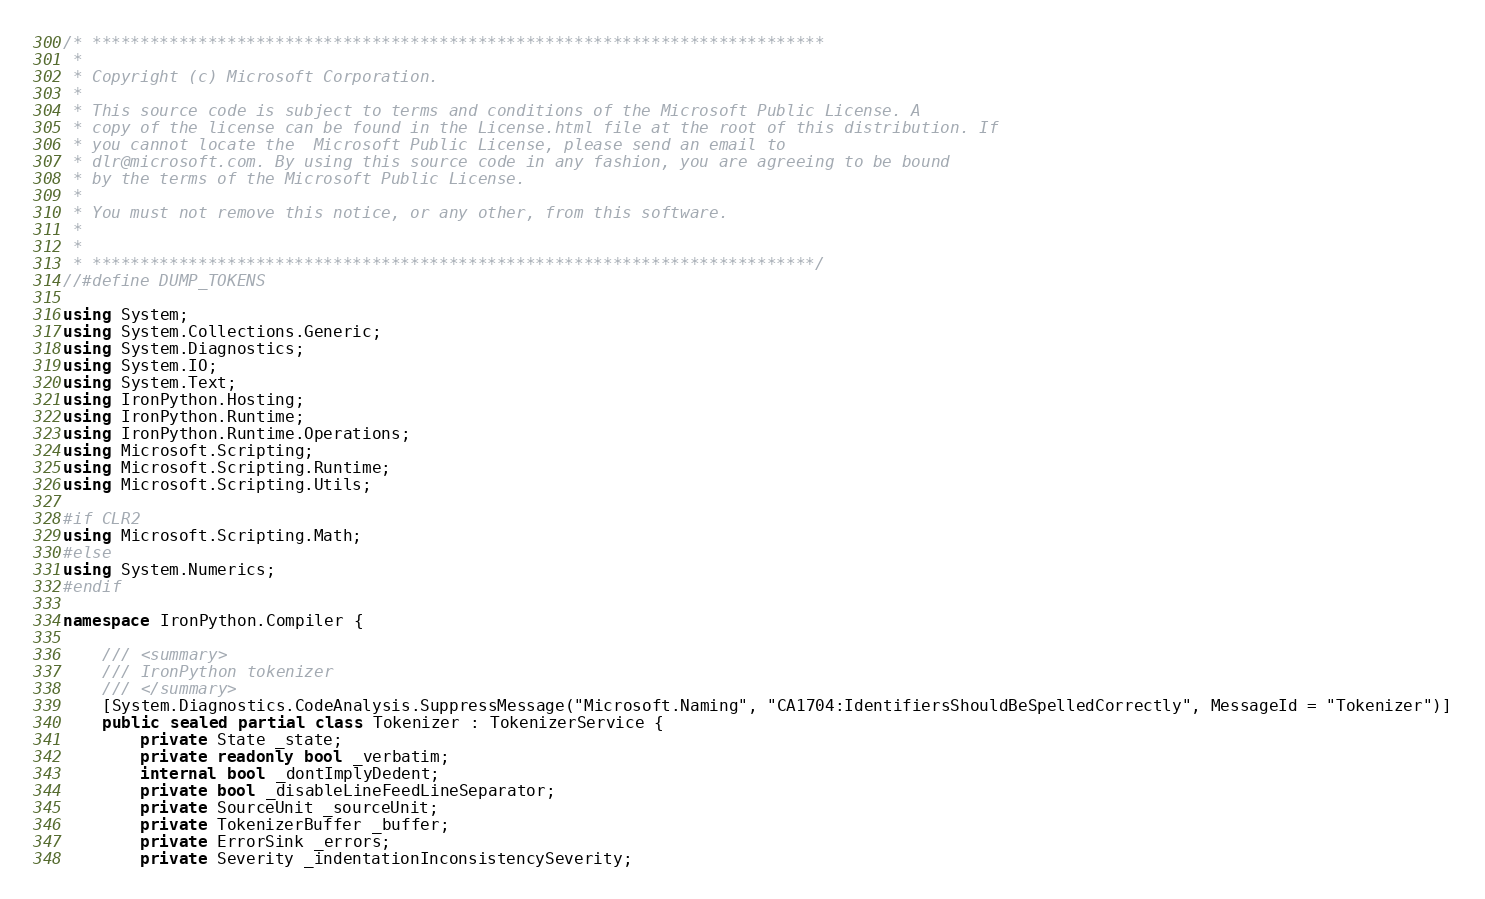Convert code to text. <code><loc_0><loc_0><loc_500><loc_500><_C#_>/* ****************************************************************************
 *
 * Copyright (c) Microsoft Corporation. 
 *
 * This source code is subject to terms and conditions of the Microsoft Public License. A 
 * copy of the license can be found in the License.html file at the root of this distribution. If 
 * you cannot locate the  Microsoft Public License, please send an email to 
 * dlr@microsoft.com. By using this source code in any fashion, you are agreeing to be bound 
 * by the terms of the Microsoft Public License.
 *
 * You must not remove this notice, or any other, from this software.
 *
 *
 * ***************************************************************************/
//#define DUMP_TOKENS

using System;
using System.Collections.Generic;
using System.Diagnostics;
using System.IO;
using System.Text;
using IronPython.Hosting;
using IronPython.Runtime;
using IronPython.Runtime.Operations;
using Microsoft.Scripting;
using Microsoft.Scripting.Runtime;
using Microsoft.Scripting.Utils;

#if CLR2
using Microsoft.Scripting.Math;
#else
using System.Numerics;
#endif

namespace IronPython.Compiler {

    /// <summary>
    /// IronPython tokenizer
    /// </summary>
    [System.Diagnostics.CodeAnalysis.SuppressMessage("Microsoft.Naming", "CA1704:IdentifiersShouldBeSpelledCorrectly", MessageId = "Tokenizer")]
    public sealed partial class Tokenizer : TokenizerService {
        private State _state;
        private readonly bool _verbatim;
        internal bool _dontImplyDedent;
        private bool _disableLineFeedLineSeparator;
        private SourceUnit _sourceUnit;
        private TokenizerBuffer _buffer;
        private ErrorSink _errors;
        private Severity _indentationInconsistencySeverity;</code> 